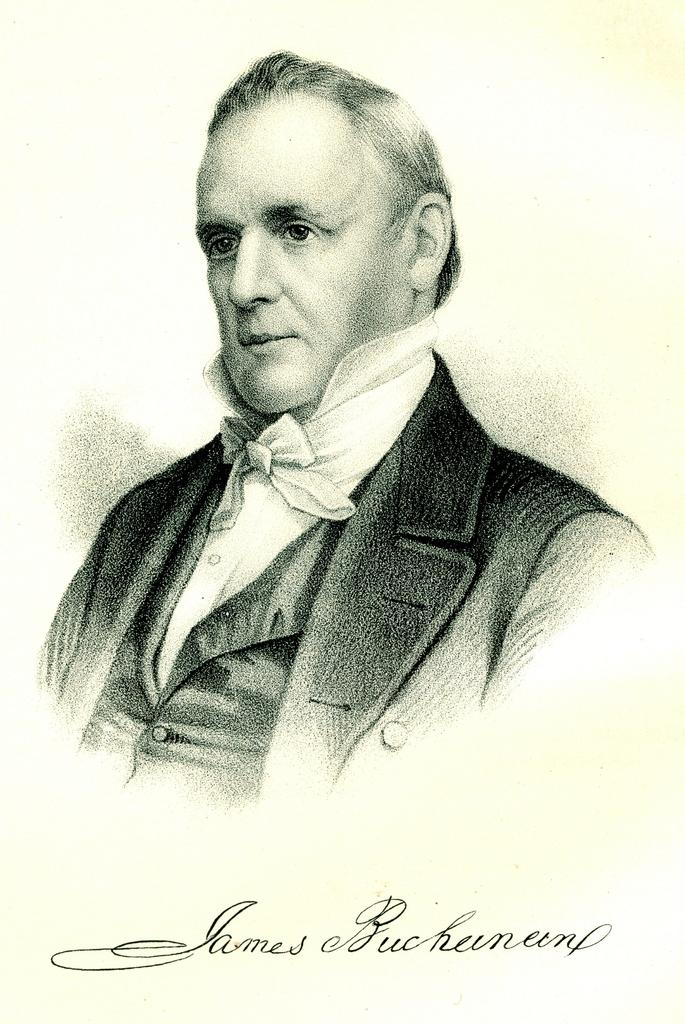What is the main subject of the image? There is a painting in the image. What does the painting depict? The painting depicts a person. What is the person in the painting wearing? The person in the painting is wearing a dress. Are there any additional elements on the painting? Yes, there is writing on the painting. What type of brake can be seen on the person in the painting? There is no brake present in the image; it is a painting of a person wearing a dress. Can you tell me how many basins are visible in the painting? There are no basins depicted in the painting; it features a person wearing a dress and has writing on it. 